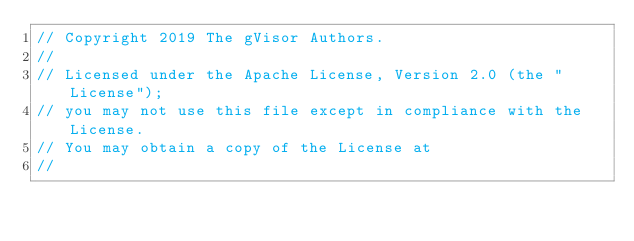Convert code to text. <code><loc_0><loc_0><loc_500><loc_500><_Go_>// Copyright 2019 The gVisor Authors.
//
// Licensed under the Apache License, Version 2.0 (the "License");
// you may not use this file except in compliance with the License.
// You may obtain a copy of the License at
//</code> 